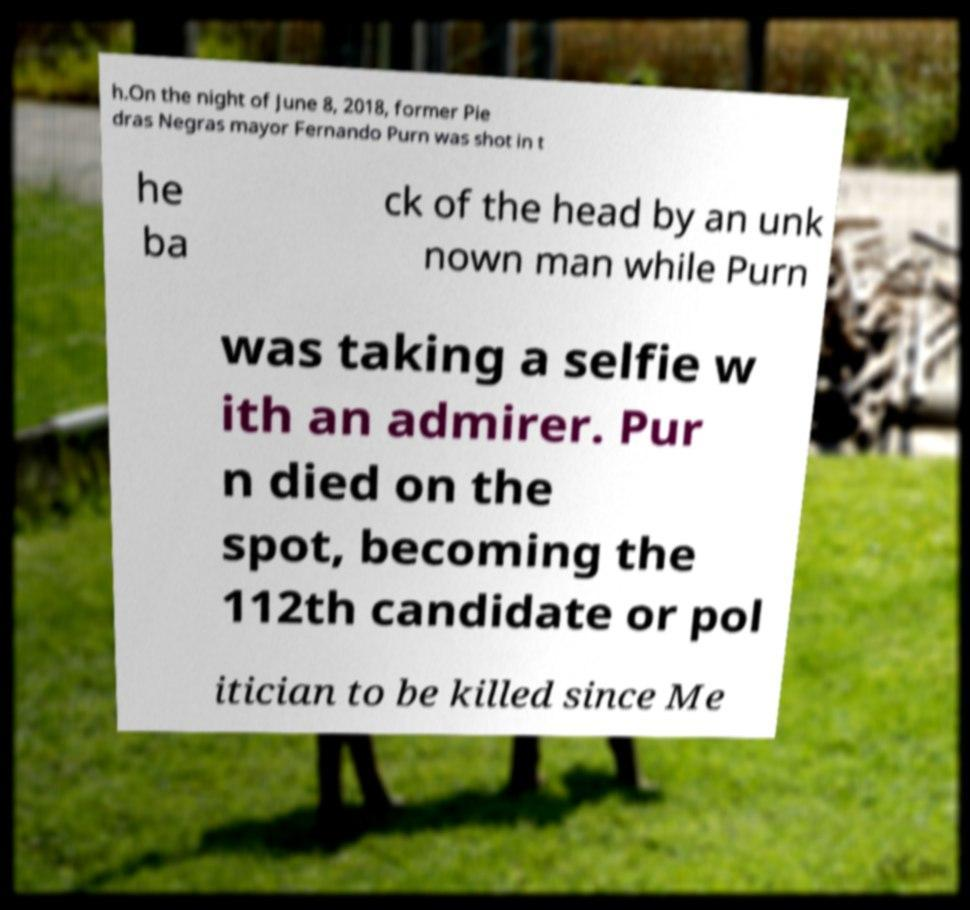Could you extract and type out the text from this image? h.On the night of June 8, 2018, former Pie dras Negras mayor Fernando Purn was shot in t he ba ck of the head by an unk nown man while Purn was taking a selfie w ith an admirer. Pur n died on the spot, becoming the 112th candidate or pol itician to be killed since Me 